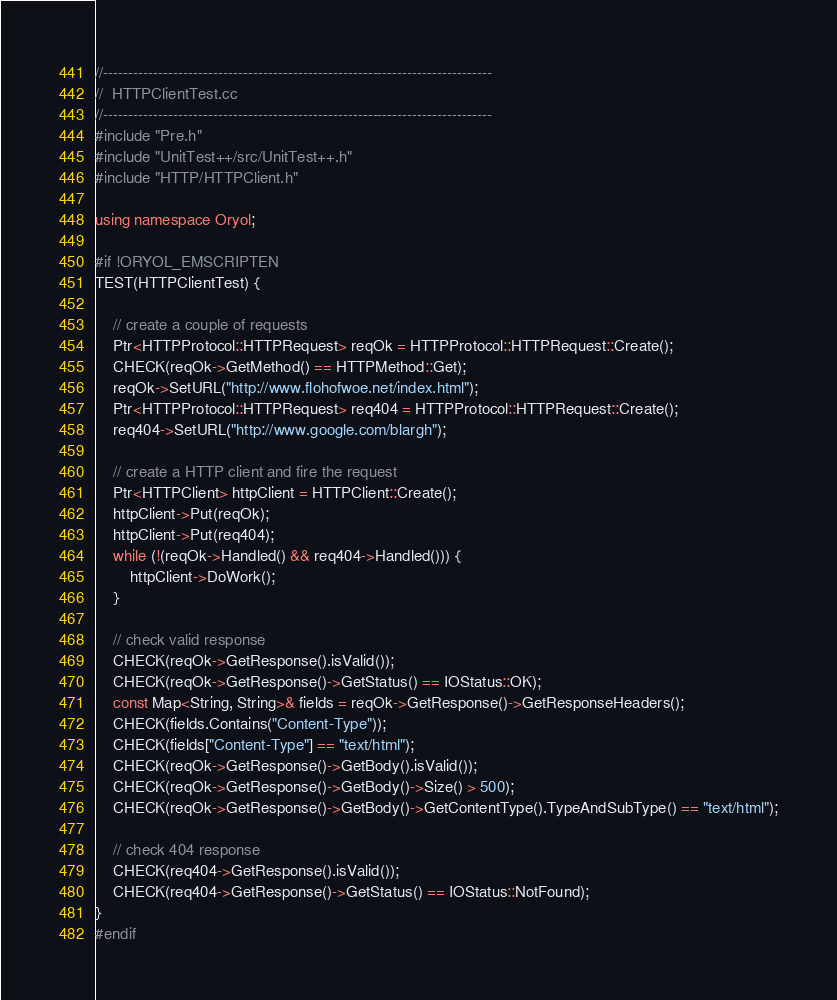<code> <loc_0><loc_0><loc_500><loc_500><_C++_>//------------------------------------------------------------------------------
//  HTTPClientTest.cc
//------------------------------------------------------------------------------
#include "Pre.h"
#include "UnitTest++/src/UnitTest++.h"
#include "HTTP/HTTPClient.h"

using namespace Oryol;

#if !ORYOL_EMSCRIPTEN
TEST(HTTPClientTest) {

    // create a couple of requests
    Ptr<HTTPProtocol::HTTPRequest> reqOk = HTTPProtocol::HTTPRequest::Create();
    CHECK(reqOk->GetMethod() == HTTPMethod::Get);
    reqOk->SetURL("http://www.flohofwoe.net/index.html");
    Ptr<HTTPProtocol::HTTPRequest> req404 = HTTPProtocol::HTTPRequest::Create();
    req404->SetURL("http://www.google.com/blargh");

    // create a HTTP client and fire the request
    Ptr<HTTPClient> httpClient = HTTPClient::Create();
    httpClient->Put(reqOk);
    httpClient->Put(req404);
    while (!(reqOk->Handled() && req404->Handled())) {
        httpClient->DoWork();
    }
    
    // check valid response
    CHECK(reqOk->GetResponse().isValid());
    CHECK(reqOk->GetResponse()->GetStatus() == IOStatus::OK);
    const Map<String, String>& fields = reqOk->GetResponse()->GetResponseHeaders();
    CHECK(fields.Contains("Content-Type"));
    CHECK(fields["Content-Type"] == "text/html");
    CHECK(reqOk->GetResponse()->GetBody().isValid());
    CHECK(reqOk->GetResponse()->GetBody()->Size() > 500);
    CHECK(reqOk->GetResponse()->GetBody()->GetContentType().TypeAndSubType() == "text/html");
    
    // check 404 response
    CHECK(req404->GetResponse().isValid());
    CHECK(req404->GetResponse()->GetStatus() == IOStatus::NotFound);
}
#endif

</code> 